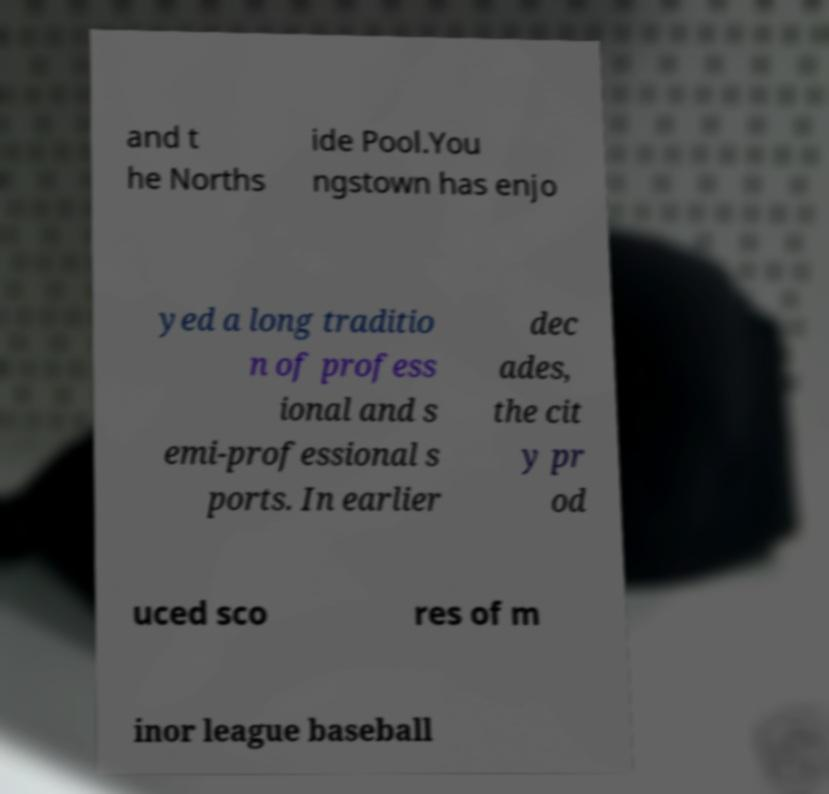There's text embedded in this image that I need extracted. Can you transcribe it verbatim? and t he Norths ide Pool.You ngstown has enjo yed a long traditio n of profess ional and s emi-professional s ports. In earlier dec ades, the cit y pr od uced sco res of m inor league baseball 